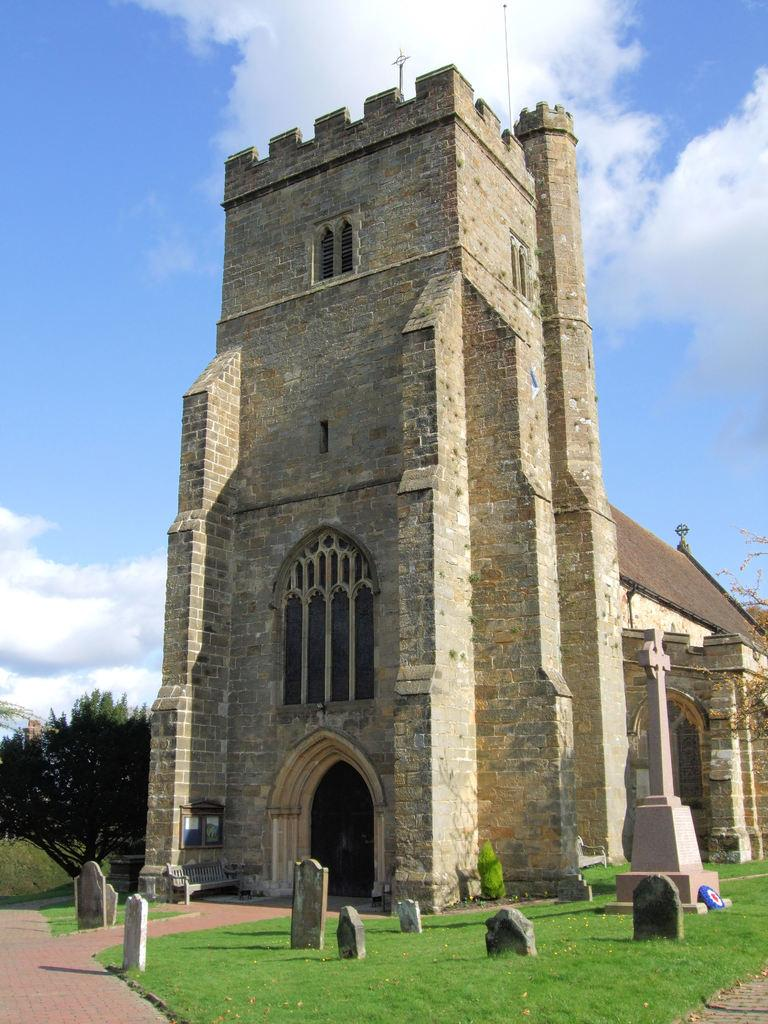What type of structure is visible in the image? There is a building in the image. What can be seen on the ground in front of the building? There are stones on a greenery ground in front of the building. Where is the tree located in the image? There is a tree in the left corner of the image. What type of spade is being used to dig near the tree in the image? There is no spade present in the image; it only features a building, stones on a greenery ground, and a tree. 